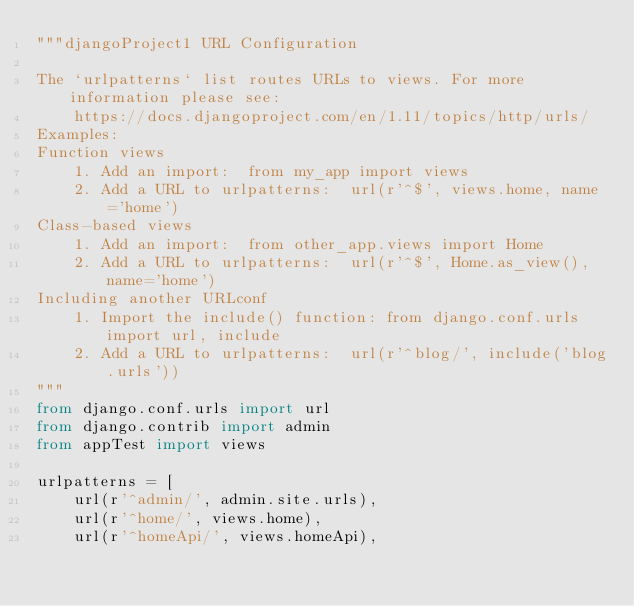<code> <loc_0><loc_0><loc_500><loc_500><_Python_>"""djangoProject1 URL Configuration

The `urlpatterns` list routes URLs to views. For more information please see:
    https://docs.djangoproject.com/en/1.11/topics/http/urls/
Examples:
Function views
    1. Add an import:  from my_app import views
    2. Add a URL to urlpatterns:  url(r'^$', views.home, name='home')
Class-based views
    1. Add an import:  from other_app.views import Home
    2. Add a URL to urlpatterns:  url(r'^$', Home.as_view(), name='home')
Including another URLconf
    1. Import the include() function: from django.conf.urls import url, include
    2. Add a URL to urlpatterns:  url(r'^blog/', include('blog.urls'))
"""
from django.conf.urls import url
from django.contrib import admin
from appTest import views

urlpatterns = [
    url(r'^admin/', admin.site.urls),
    url(r'^home/', views.home),
    url(r'^homeApi/', views.homeApi),</code> 